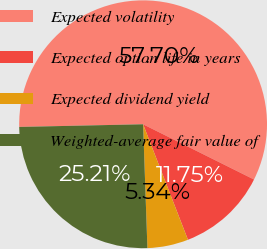Convert chart to OTSL. <chart><loc_0><loc_0><loc_500><loc_500><pie_chart><fcel>Expected volatility<fcel>Expected option life in years<fcel>Expected dividend yield<fcel>Weighted-average fair value of<nl><fcel>57.69%<fcel>11.75%<fcel>5.34%<fcel>25.21%<nl></chart> 